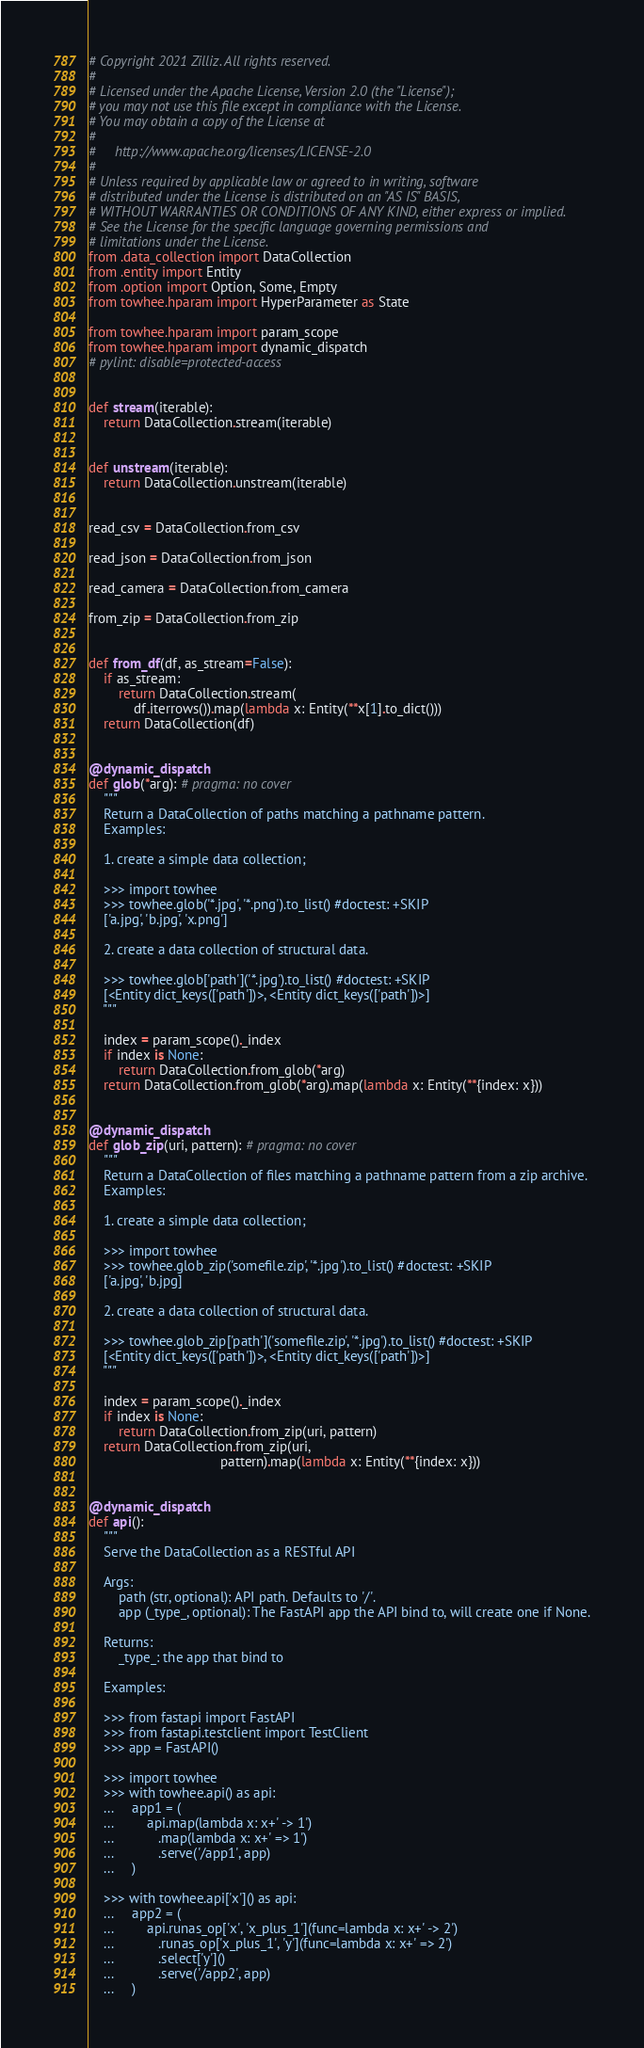<code> <loc_0><loc_0><loc_500><loc_500><_Python_># Copyright 2021 Zilliz. All rights reserved.
#
# Licensed under the Apache License, Version 2.0 (the "License");
# you may not use this file except in compliance with the License.
# You may obtain a copy of the License at
#
#     http://www.apache.org/licenses/LICENSE-2.0
#
# Unless required by applicable law or agreed to in writing, software
# distributed under the License is distributed on an "AS IS" BASIS,
# WITHOUT WARRANTIES OR CONDITIONS OF ANY KIND, either express or implied.
# See the License for the specific language governing permissions and
# limitations under the License.
from .data_collection import DataCollection
from .entity import Entity
from .option import Option, Some, Empty
from towhee.hparam import HyperParameter as State

from towhee.hparam import param_scope
from towhee.hparam import dynamic_dispatch
# pylint: disable=protected-access


def stream(iterable):
    return DataCollection.stream(iterable)


def unstream(iterable):
    return DataCollection.unstream(iterable)


read_csv = DataCollection.from_csv

read_json = DataCollection.from_json

read_camera = DataCollection.from_camera

from_zip = DataCollection.from_zip


def from_df(df, as_stream=False):
    if as_stream:
        return DataCollection.stream(
            df.iterrows()).map(lambda x: Entity(**x[1].to_dict()))
    return DataCollection(df)


@dynamic_dispatch
def glob(*arg): # pragma: no cover
    """
    Return a DataCollection of paths matching a pathname pattern.
    Examples:

    1. create a simple data collection;

    >>> import towhee
    >>> towhee.glob('*.jpg', '*.png').to_list() #doctest: +SKIP
    ['a.jpg', 'b.jpg', 'x.png']

    2. create a data collection of structural data.

    >>> towhee.glob['path']('*.jpg').to_list() #doctest: +SKIP
    [<Entity dict_keys(['path'])>, <Entity dict_keys(['path'])>]
    """

    index = param_scope()._index
    if index is None:
        return DataCollection.from_glob(*arg)
    return DataCollection.from_glob(*arg).map(lambda x: Entity(**{index: x}))


@dynamic_dispatch
def glob_zip(uri, pattern): # pragma: no cover
    """
    Return a DataCollection of files matching a pathname pattern from a zip archive.
    Examples:

    1. create a simple data collection;

    >>> import towhee
    >>> towhee.glob_zip('somefile.zip', '*.jpg').to_list() #doctest: +SKIP
    ['a.jpg', 'b.jpg]

    2. create a data collection of structural data.

    >>> towhee.glob_zip['path']('somefile.zip', '*.jpg').to_list() #doctest: +SKIP
    [<Entity dict_keys(['path'])>, <Entity dict_keys(['path'])>]
    """

    index = param_scope()._index
    if index is None:
        return DataCollection.from_zip(uri, pattern)
    return DataCollection.from_zip(uri,
                                   pattern).map(lambda x: Entity(**{index: x}))


@dynamic_dispatch
def api():
    """
    Serve the DataCollection as a RESTful API

    Args:
        path (str, optional): API path. Defaults to '/'.
        app (_type_, optional): The FastAPI app the API bind to, will create one if None.

    Returns:
        _type_: the app that bind to

    Examples:

    >>> from fastapi import FastAPI
    >>> from fastapi.testclient import TestClient
    >>> app = FastAPI()

    >>> import towhee
    >>> with towhee.api() as api:
    ...     app1 = (
    ...         api.map(lambda x: x+' -> 1')
    ...            .map(lambda x: x+' => 1')
    ...            .serve('/app1', app)
    ...     )

    >>> with towhee.api['x']() as api:
    ...     app2 = (
    ...         api.runas_op['x', 'x_plus_1'](func=lambda x: x+' -> 2')
    ...            .runas_op['x_plus_1', 'y'](func=lambda x: x+' => 2')
    ...            .select['y']()
    ...            .serve('/app2', app)
    ...     )
</code> 